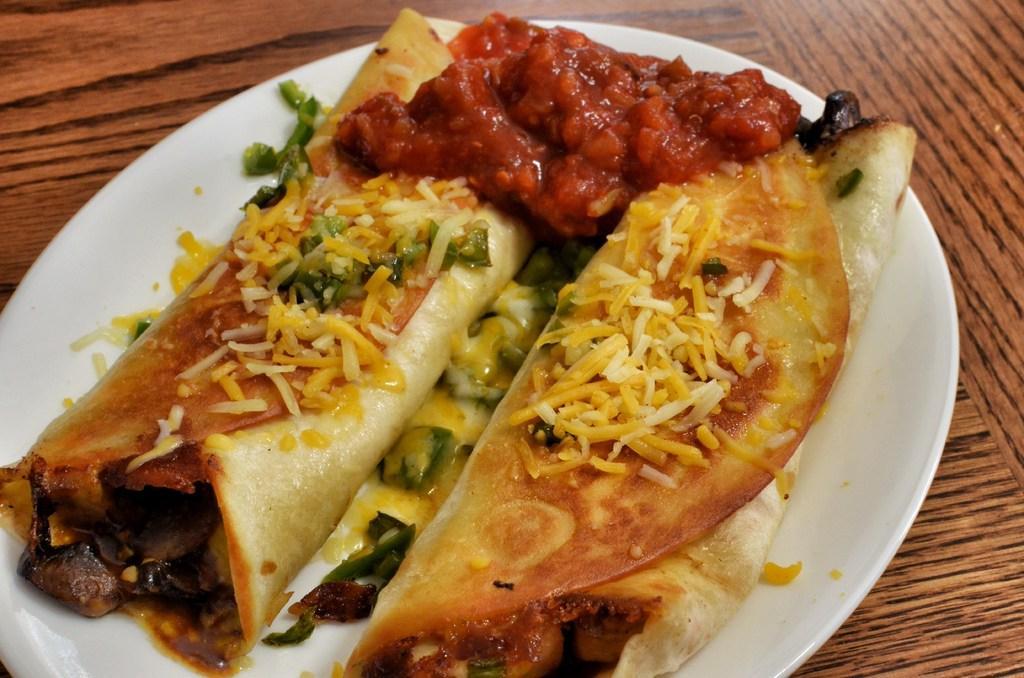How would you summarize this image in a sentence or two? In this picture we can see a white plate with food items on it and this plate is placed on the wooden surface. 